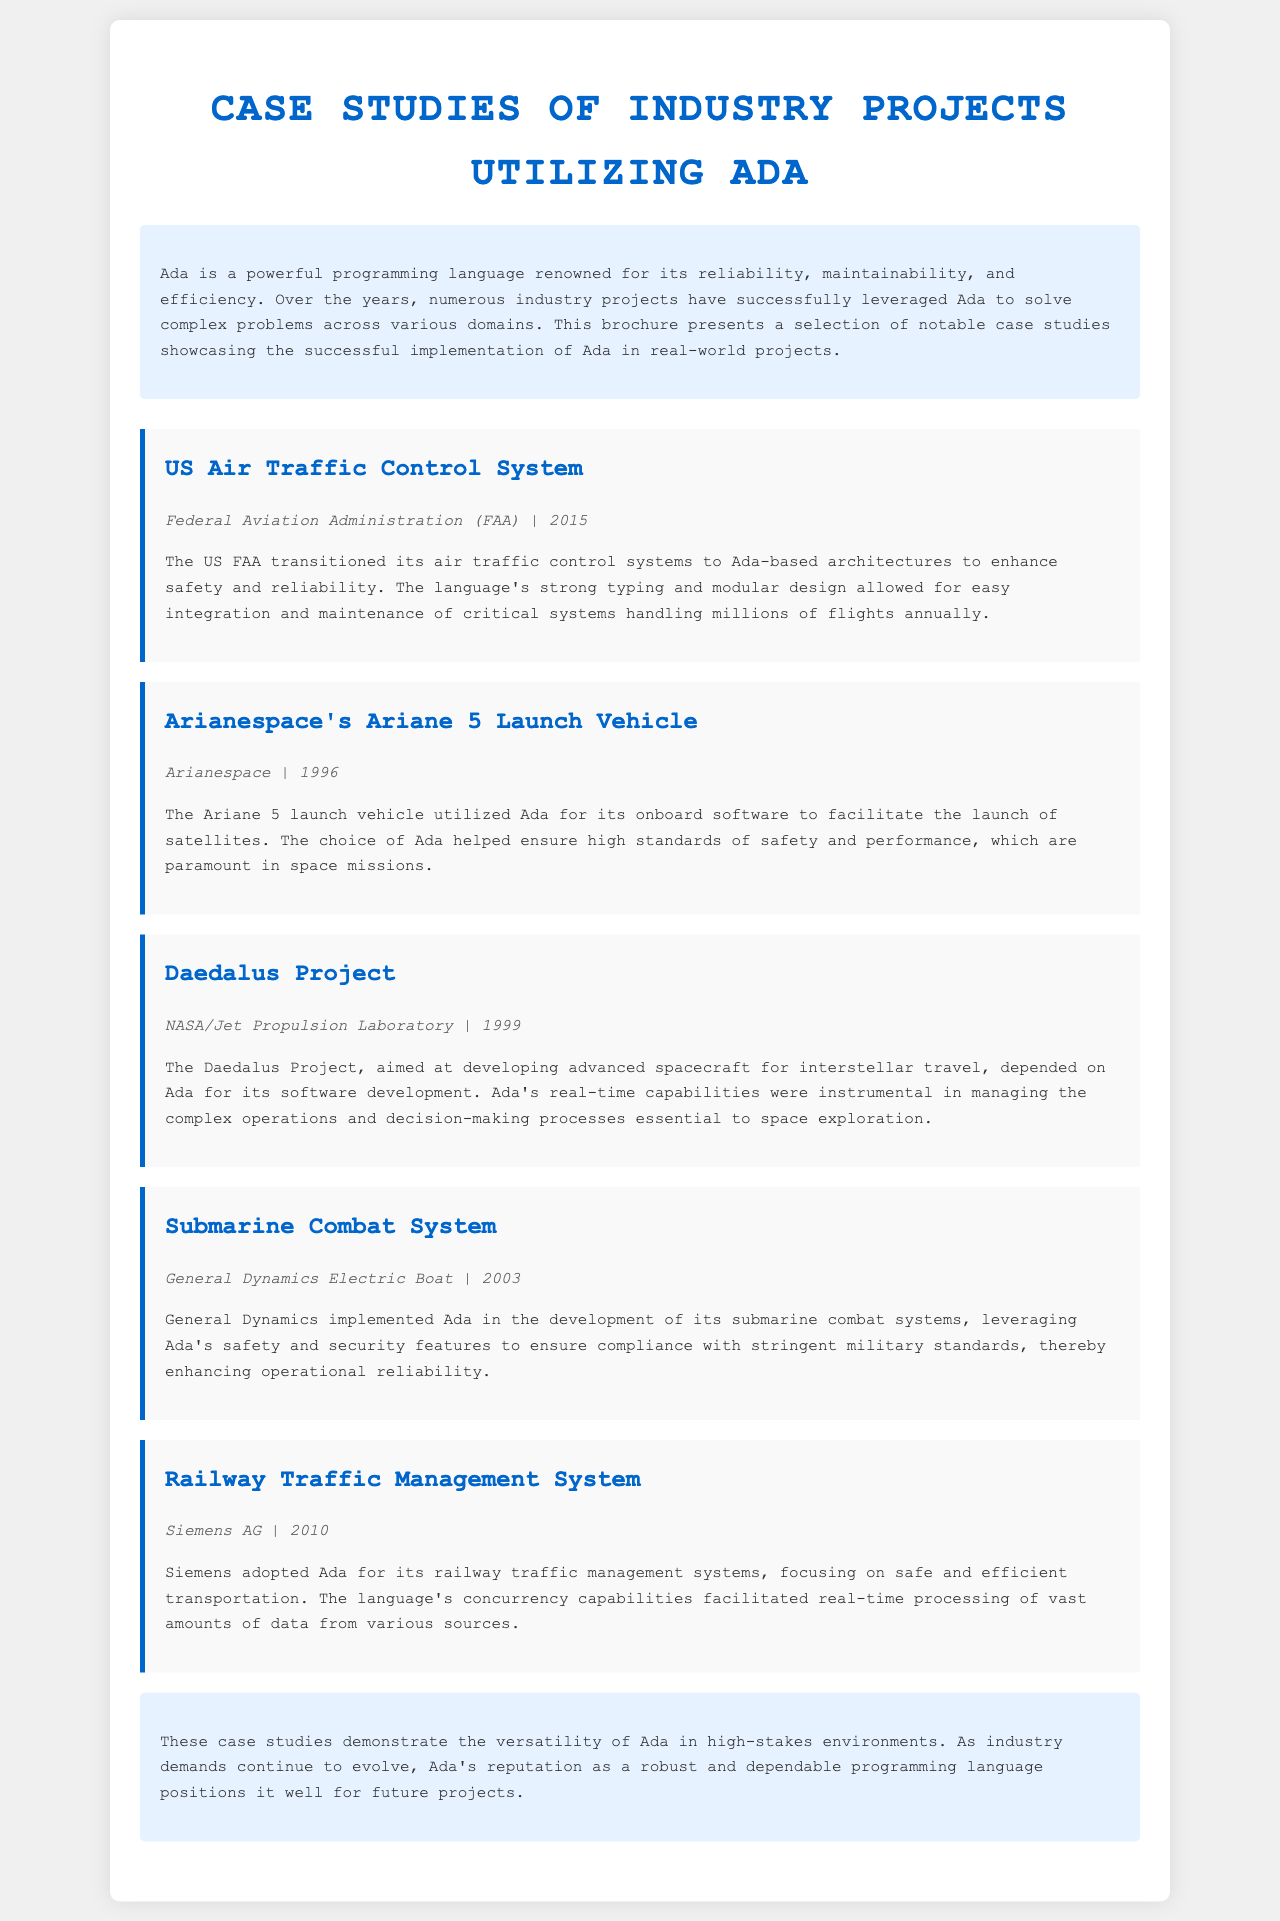what is the title of the brochure? The title is displayed prominently at the top of the document.
Answer: Case Studies of Industry Projects Utilizing Ada who implemented Ada for the Submarine Combat System? This information is found in the case studies section of the document.
Answer: General Dynamics Electric Boat what year was the Ariane 5 Launch Vehicle project completed? The completion year is indicated in the case details.
Answer: 1996 which organization is associated with the US Air Traffic Control System case study? This is provided in the case study section.
Answer: Federal Aviation Administration (FAA) what is one key feature of Ada highlighted in the brochure? The description in the introduction mentions specific features of Ada.
Answer: Reliability which case study focused on advance spacecraft for interstellar travel? The title of the specific case study reveals this information.
Answer: Daedalus Project how many case studies are presented in the brochure? Each case study is formatted separately in the document.
Answer: Five what company used Ada for Railway Traffic Management Systems? The corresponding case study provides the organization’s name.
Answer: Siemens AG what is the main theme presented in the conclusion of the brochure? The conclusion summarizes the overall message regarding Ada's capabilities.
Answer: Versatility 